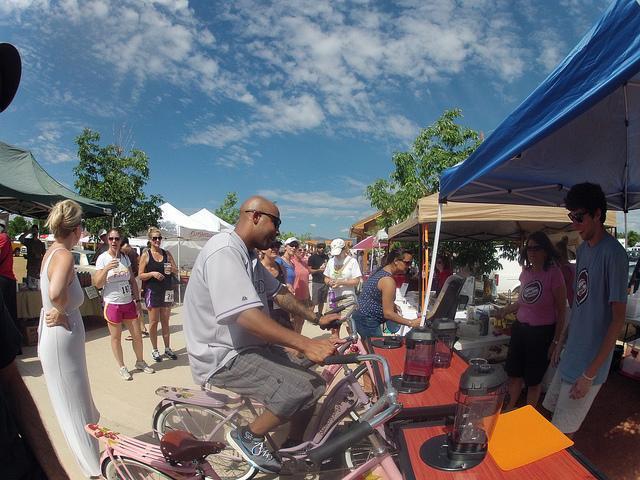How many people are in the picture?
Give a very brief answer. 7. How many bicycles can you see?
Give a very brief answer. 2. How many animals that are zebras are there? there are animals that aren't zebras too?
Give a very brief answer. 0. 